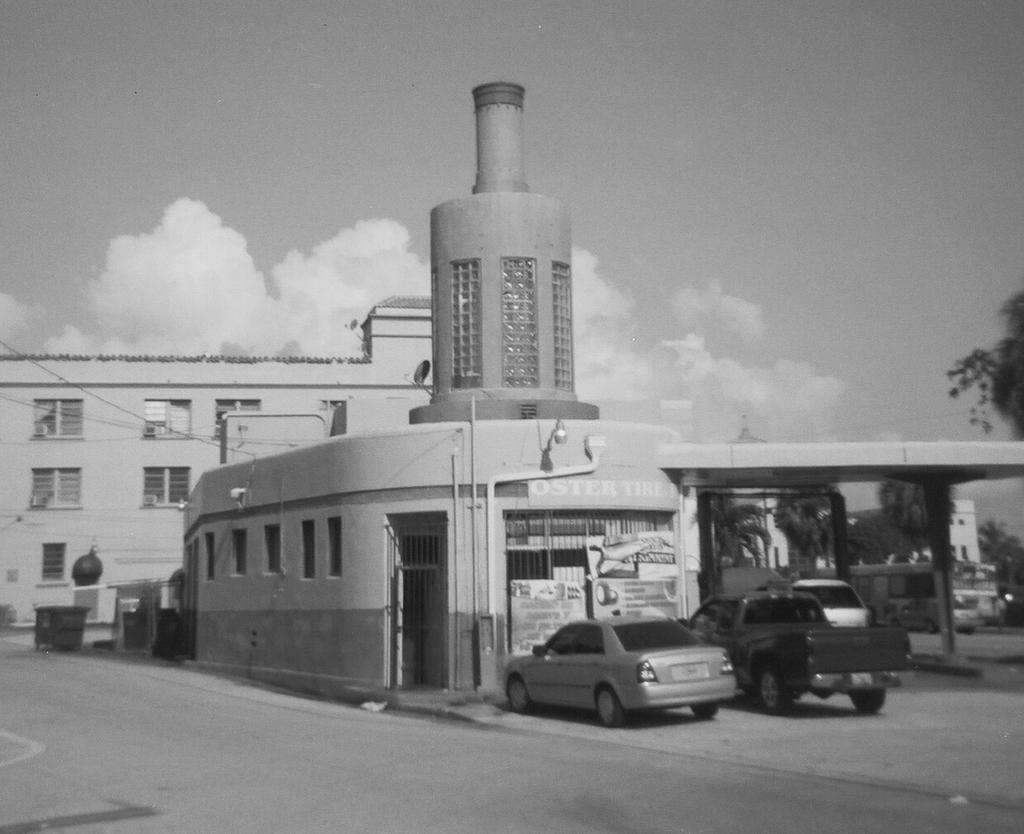What type of structures can be seen in the image? There are buildings in the image. What feature do the buildings have? The buildings have windows. What else can be seen in the image besides the buildings? There are cars visible in the image. Are there any signs or notices associated with the buildings? Yes, there are boards associated with the buildings. What type of vegetation is present in the image? There is a tree present in the image. What color is the thread used to tie the neck of the tub in the image? There is no tub, thread, or neck present in the image. 